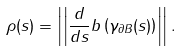Convert formula to latex. <formula><loc_0><loc_0><loc_500><loc_500>\rho ( s ) = \left | \left | \frac { d } { d s } b \left ( \gamma _ { \partial B } ( s ) \right ) \right | \right | .</formula> 